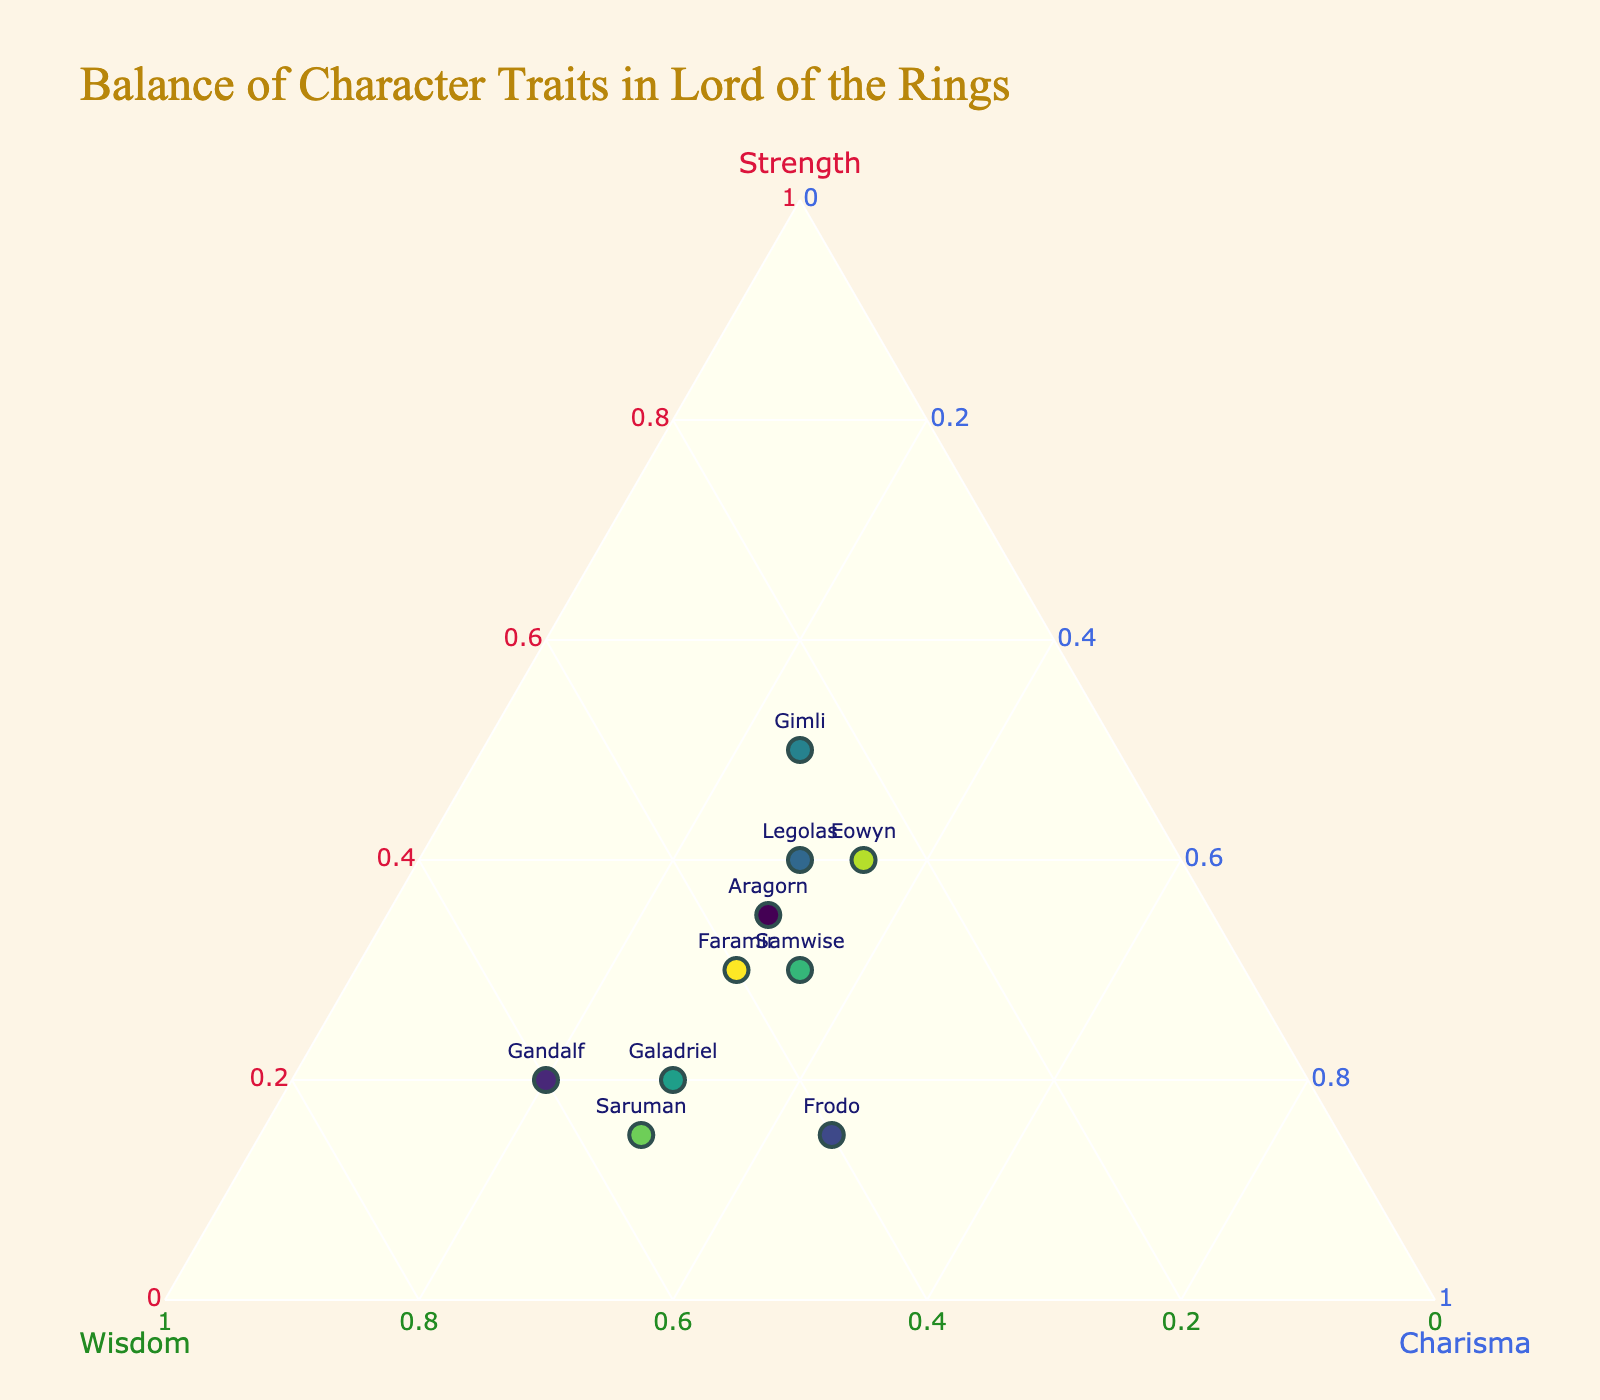What is the title of the figure? The title is located at the top of the figure. It explains the overall topic or theme of the visualization.
Answer: Balance of Character Traits in Lord of the Rings Which character has the highest strength value? The strength values are represented on the left axis of the ternary plot. Look for the character positioned furthest along the strength axis.
Answer: Gimli Which character's traits are most balanced among strength, wisdom, and charisma? To find the most balanced character, look for a point that is closest to the center of the triangle, as it indicates roughly equal portions of each trait.
Answer: Aragorn How many characters have more charisma than wisdom? Compare each character's position relative to the wisdom (bottom axis) and charisma (right axis). Count characters who are positioned closer to the charisma side.
Answer: Three (Frodo, Eowyn, Samwise) Which character has almost equal amounts of strength and wisdom but less charisma? Look for a point near the 50% mark on both the strength and wisdom axes but lower on the charisma axis.
Answer: Gandalf Who has greater wisdom: Galadriel or Frodo? Compare the positions of Galadriel and Frodo along the wisdom (bottom) axis. The point further to the wisdom side represents the character with greater wisdom.
Answer: Galadriel Which character has the lowest amount of strength? Identify the character positioned closest to the side opposite the strength corner of the triangle.
Answer: Frodo Are there any characters whose traits form an exact 1:1:1 ratio? Look for a point exactly at the center where all three traits (strength, wisdom, and charisma) are equal. Verify none of the characters are positioned there.
Answer: No How does Samwise's charisma compare to Aragorn's and Frodo's? Check their positions along the charisma (right) axis. Compare the distances from the base to these characters' markers.
Answer: Samwise's charisma is equal to Frodo's but more than Aragorn's Which two characters have the same amount of strength? Identify characters positioned equally along the strength (left) axis.
Answer: Aragorn and Samwise 